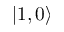Convert formula to latex. <formula><loc_0><loc_0><loc_500><loc_500>| 1 , 0 \rangle</formula> 